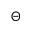Convert formula to latex. <formula><loc_0><loc_0><loc_500><loc_500>\Theta</formula> 